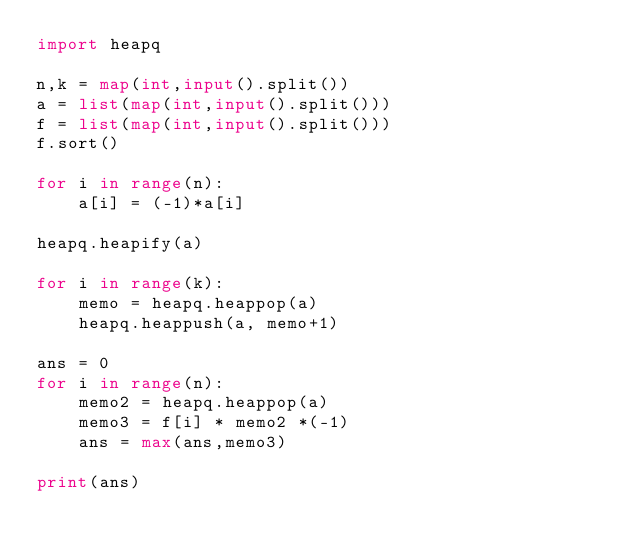Convert code to text. <code><loc_0><loc_0><loc_500><loc_500><_Python_>import heapq

n,k = map(int,input().split())
a = list(map(int,input().split()))
f = list(map(int,input().split()))
f.sort()

for i in range(n):
    a[i] = (-1)*a[i]

heapq.heapify(a)

for i in range(k):
    memo = heapq.heappop(a)
    heapq.heappush(a, memo+1)

ans = 0
for i in range(n):
    memo2 = heapq.heappop(a)
    memo3 = f[i] * memo2 *(-1)
    ans = max(ans,memo3)

print(ans)</code> 